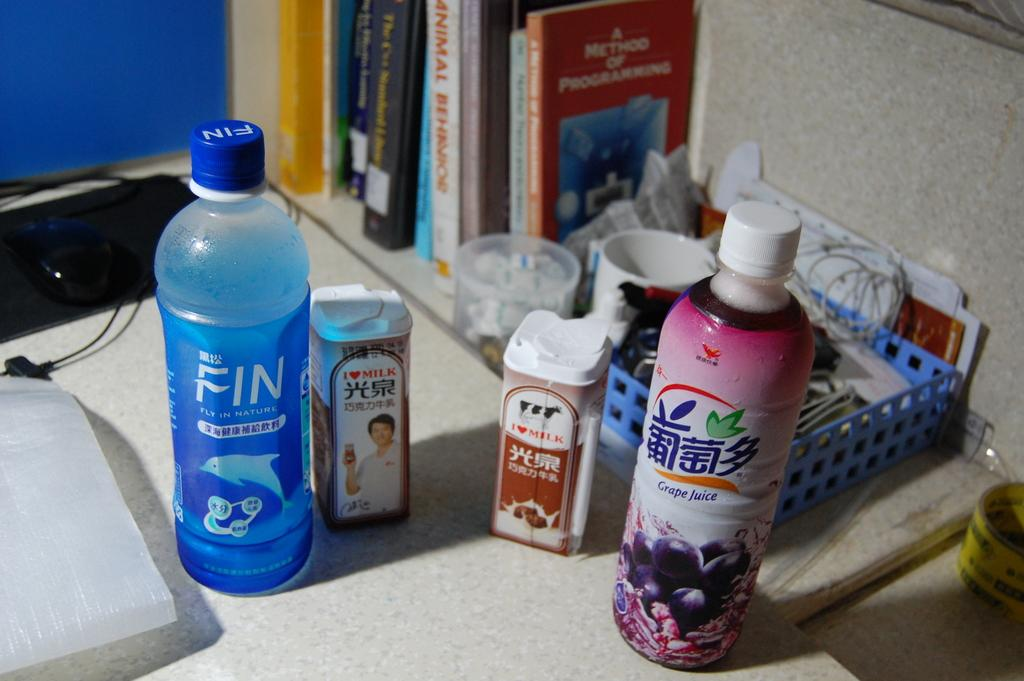<image>
Render a clear and concise summary of the photo. A Fly In Nature bottle sits on a counter next to other products. 